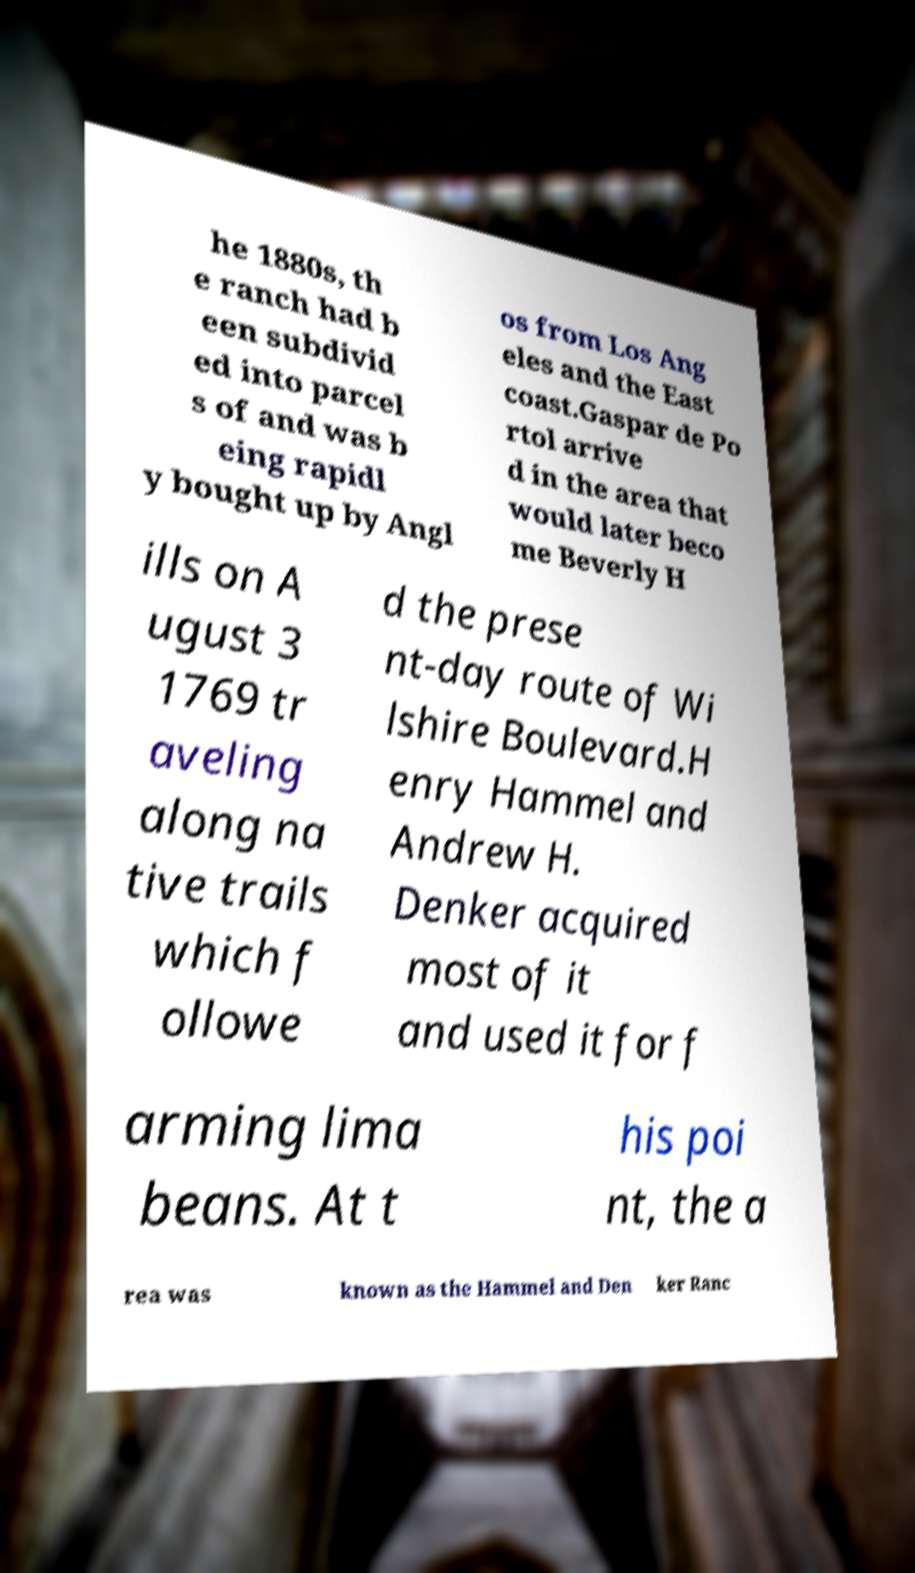Can you read and provide the text displayed in the image?This photo seems to have some interesting text. Can you extract and type it out for me? he 1880s, th e ranch had b een subdivid ed into parcel s of and was b eing rapidl y bought up by Angl os from Los Ang eles and the East coast.Gaspar de Po rtol arrive d in the area that would later beco me Beverly H ills on A ugust 3 1769 tr aveling along na tive trails which f ollowe d the prese nt-day route of Wi lshire Boulevard.H enry Hammel and Andrew H. Denker acquired most of it and used it for f arming lima beans. At t his poi nt, the a rea was known as the Hammel and Den ker Ranc 